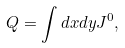Convert formula to latex. <formula><loc_0><loc_0><loc_500><loc_500>Q = \int d x d y J ^ { 0 } ,</formula> 